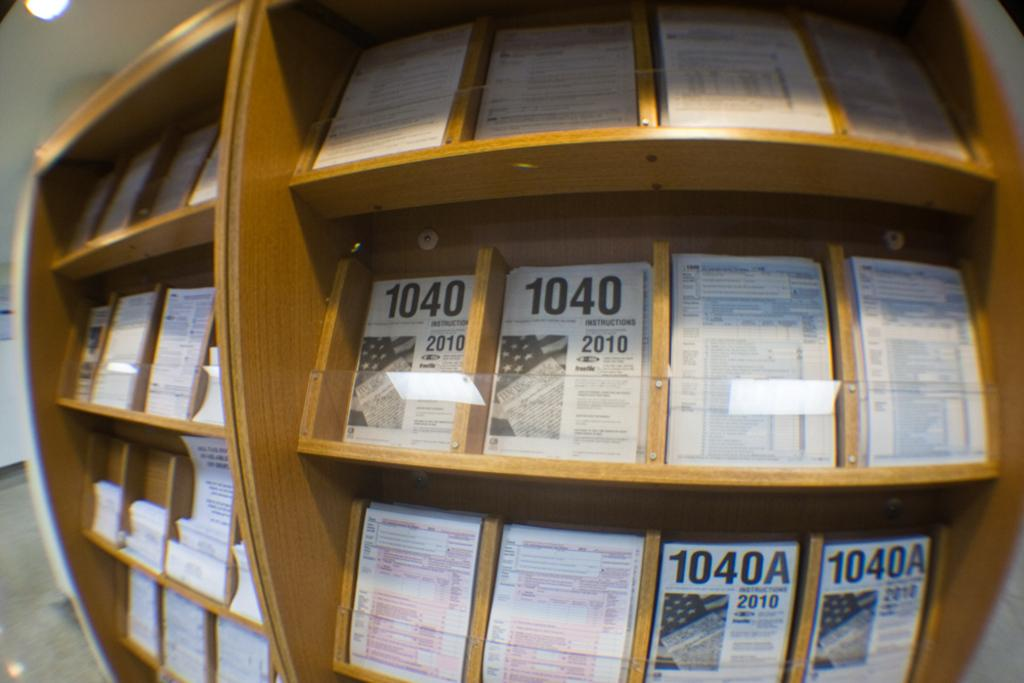<image>
Offer a succinct explanation of the picture presented. a shelf full of forms, including the 1040 and 1040A for 2010 